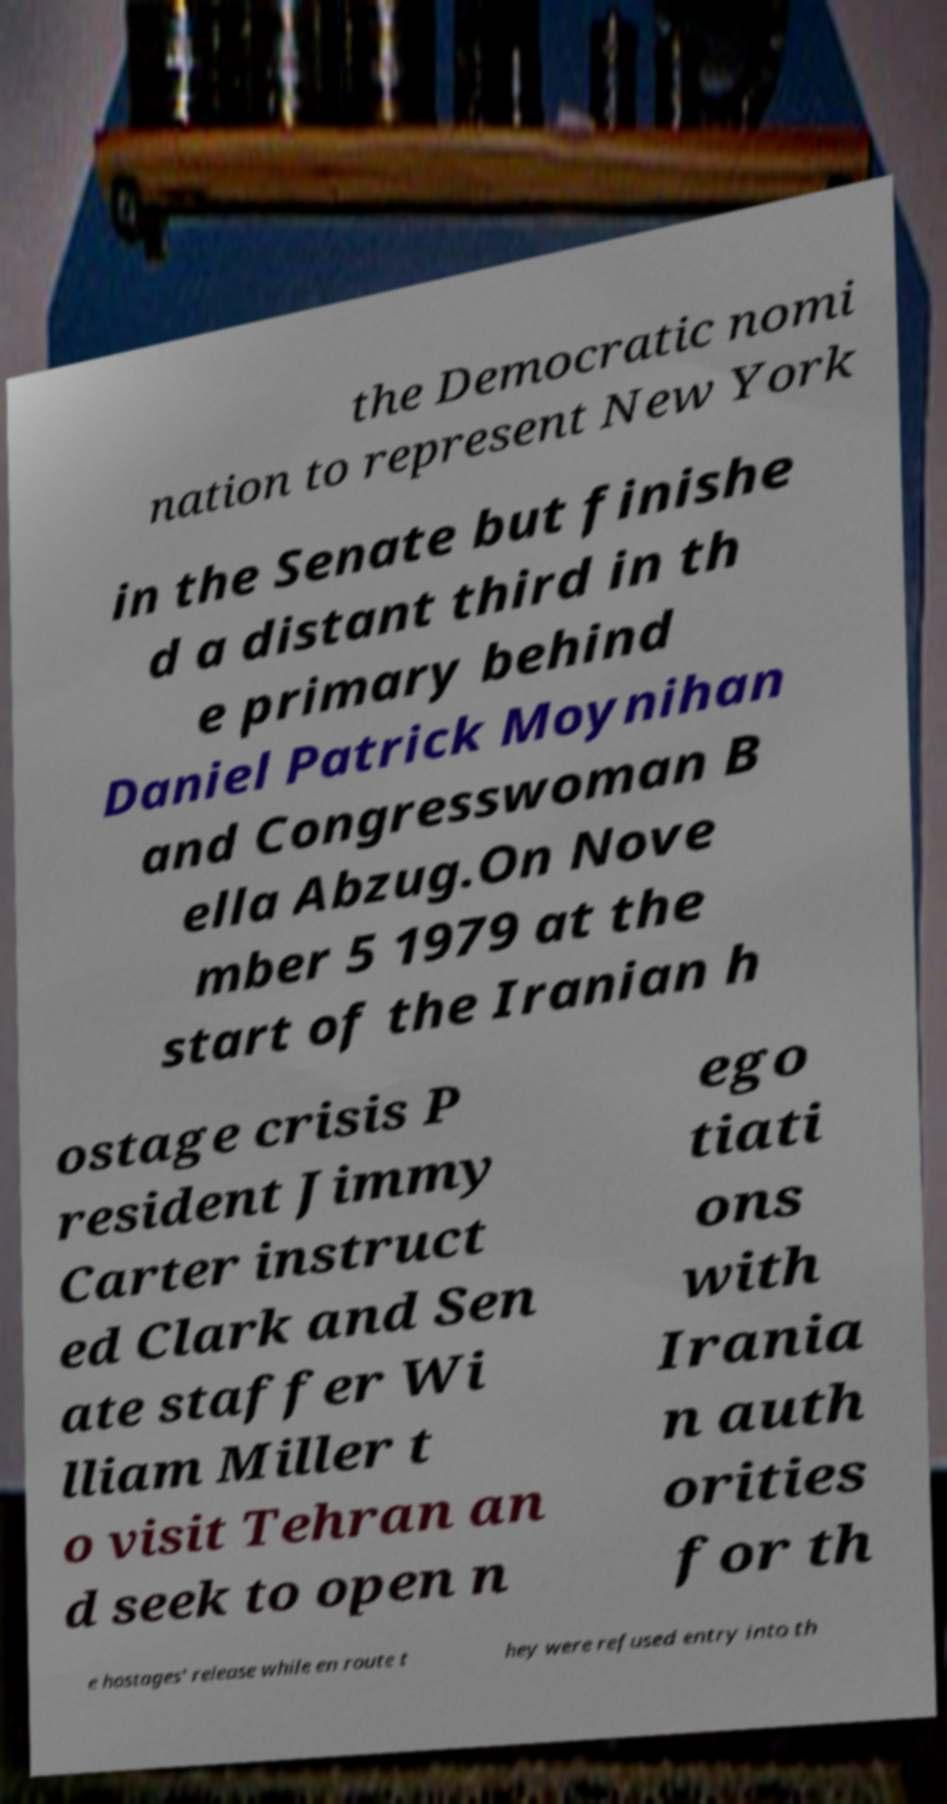Can you accurately transcribe the text from the provided image for me? the Democratic nomi nation to represent New York in the Senate but finishe d a distant third in th e primary behind Daniel Patrick Moynihan and Congresswoman B ella Abzug.On Nove mber 5 1979 at the start of the Iranian h ostage crisis P resident Jimmy Carter instruct ed Clark and Sen ate staffer Wi lliam Miller t o visit Tehran an d seek to open n ego tiati ons with Irania n auth orities for th e hostages' release while en route t hey were refused entry into th 